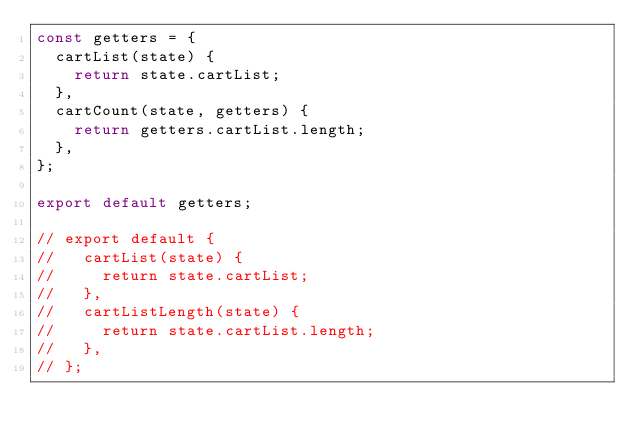Convert code to text. <code><loc_0><loc_0><loc_500><loc_500><_JavaScript_>const getters = {
  cartList(state) {
    return state.cartList;
  },
  cartCount(state, getters) {
    return getters.cartList.length;
  },
};

export default getters;

// export default {
//   cartList(state) {
//     return state.cartList;
//   },
//   cartListLength(state) {
//     return state.cartList.length;
//   },
// };
</code> 